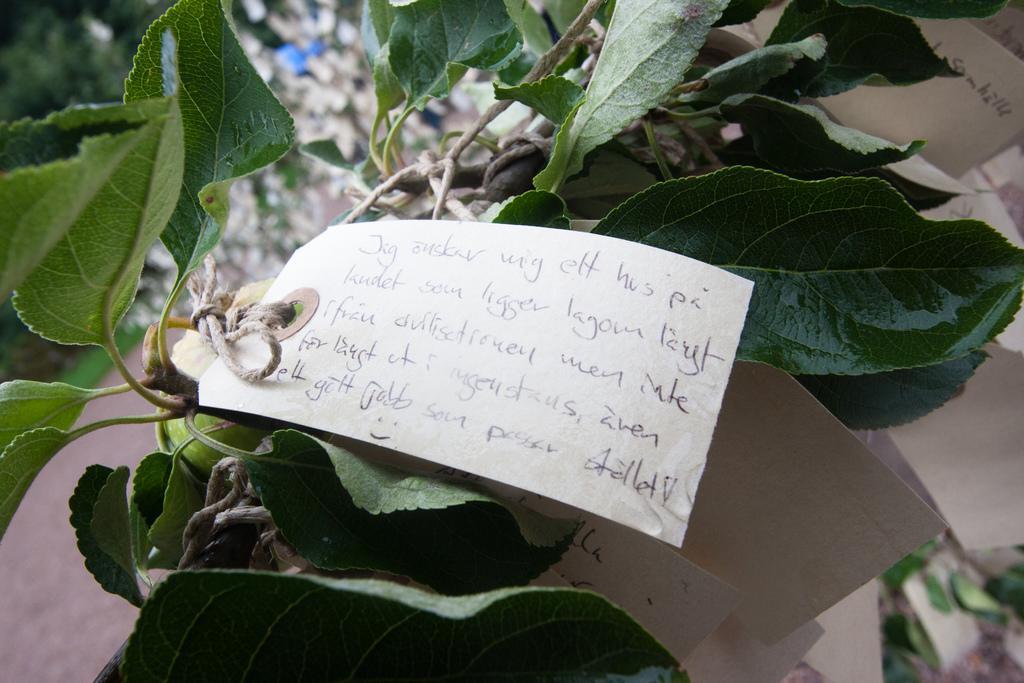Can you describe this image briefly? In this picture I can see in the middle there is a paper with text written on it and tied to the the plant. 